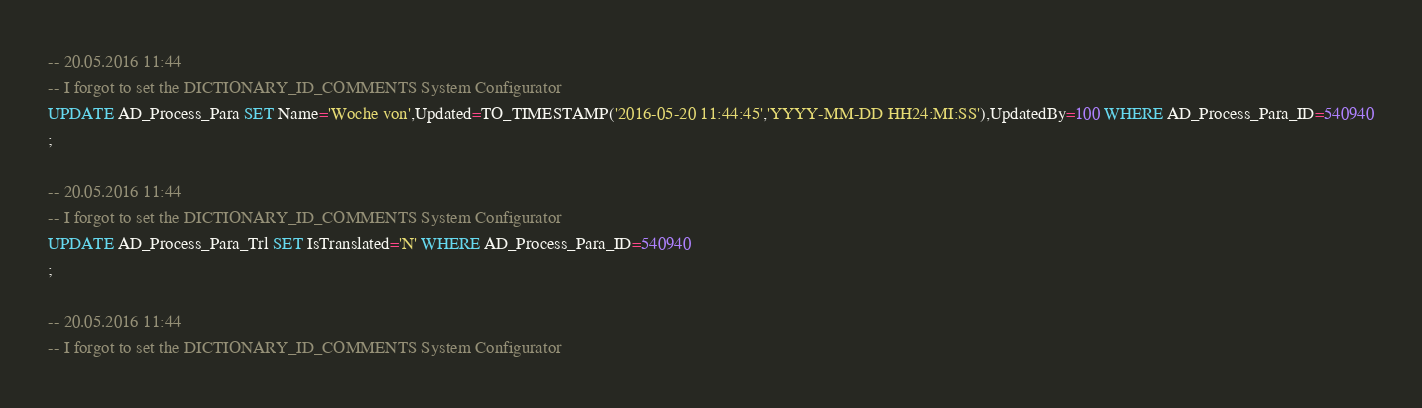Convert code to text. <code><loc_0><loc_0><loc_500><loc_500><_SQL_>-- 20.05.2016 11:44
-- I forgot to set the DICTIONARY_ID_COMMENTS System Configurator
UPDATE AD_Process_Para SET Name='Woche von',Updated=TO_TIMESTAMP('2016-05-20 11:44:45','YYYY-MM-DD HH24:MI:SS'),UpdatedBy=100 WHERE AD_Process_Para_ID=540940
;

-- 20.05.2016 11:44
-- I forgot to set the DICTIONARY_ID_COMMENTS System Configurator
UPDATE AD_Process_Para_Trl SET IsTranslated='N' WHERE AD_Process_Para_ID=540940
;

-- 20.05.2016 11:44
-- I forgot to set the DICTIONARY_ID_COMMENTS System Configurator</code> 